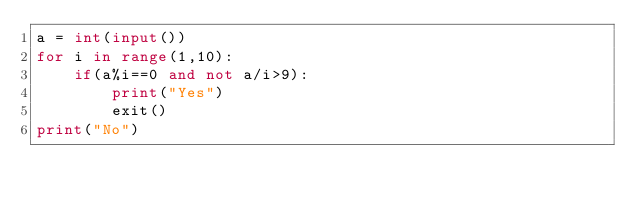Convert code to text. <code><loc_0><loc_0><loc_500><loc_500><_Python_>a = int(input())
for i in range(1,10):
    if(a%i==0 and not a/i>9):
        print("Yes")
        exit()
print("No")
</code> 